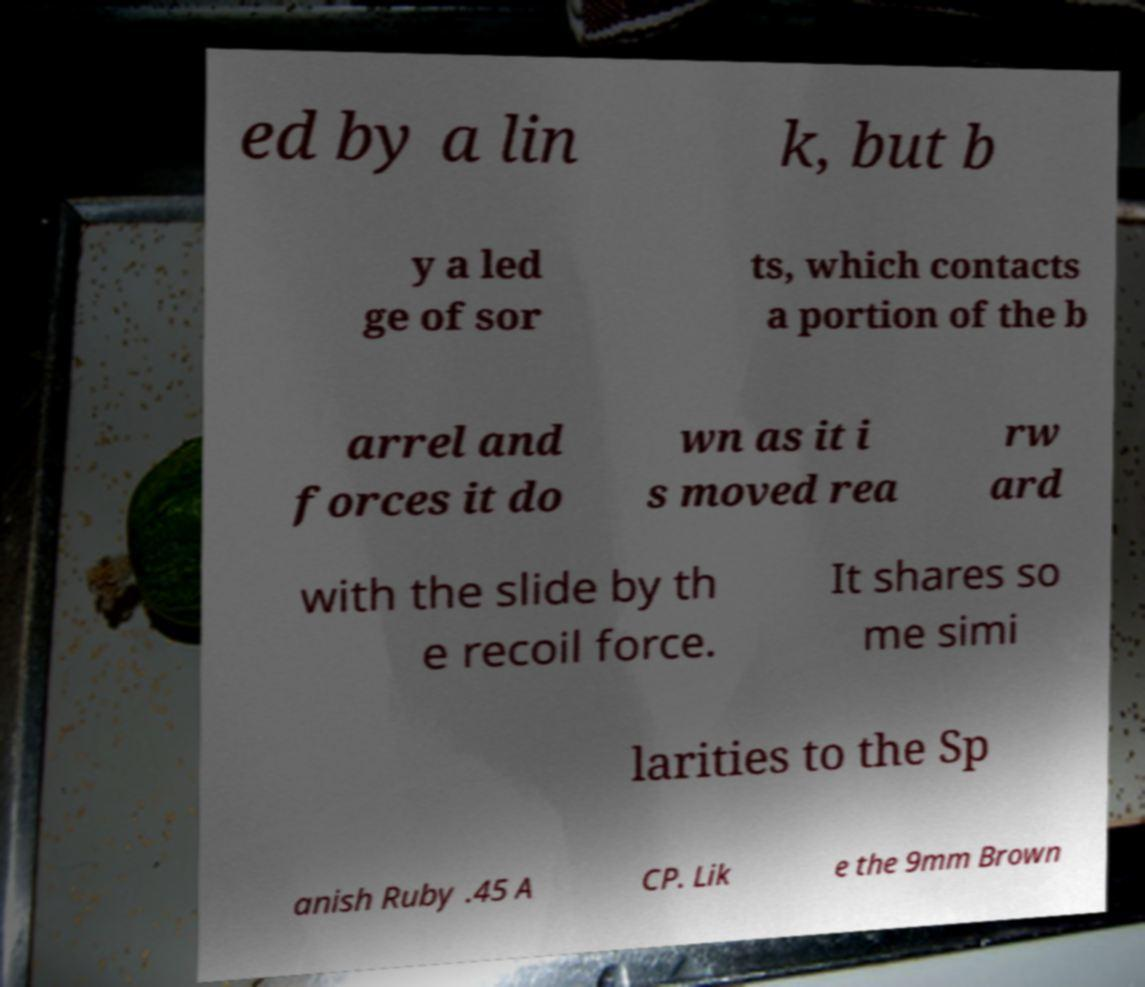Please identify and transcribe the text found in this image. ed by a lin k, but b y a led ge of sor ts, which contacts a portion of the b arrel and forces it do wn as it i s moved rea rw ard with the slide by th e recoil force. It shares so me simi larities to the Sp anish Ruby .45 A CP. Lik e the 9mm Brown 